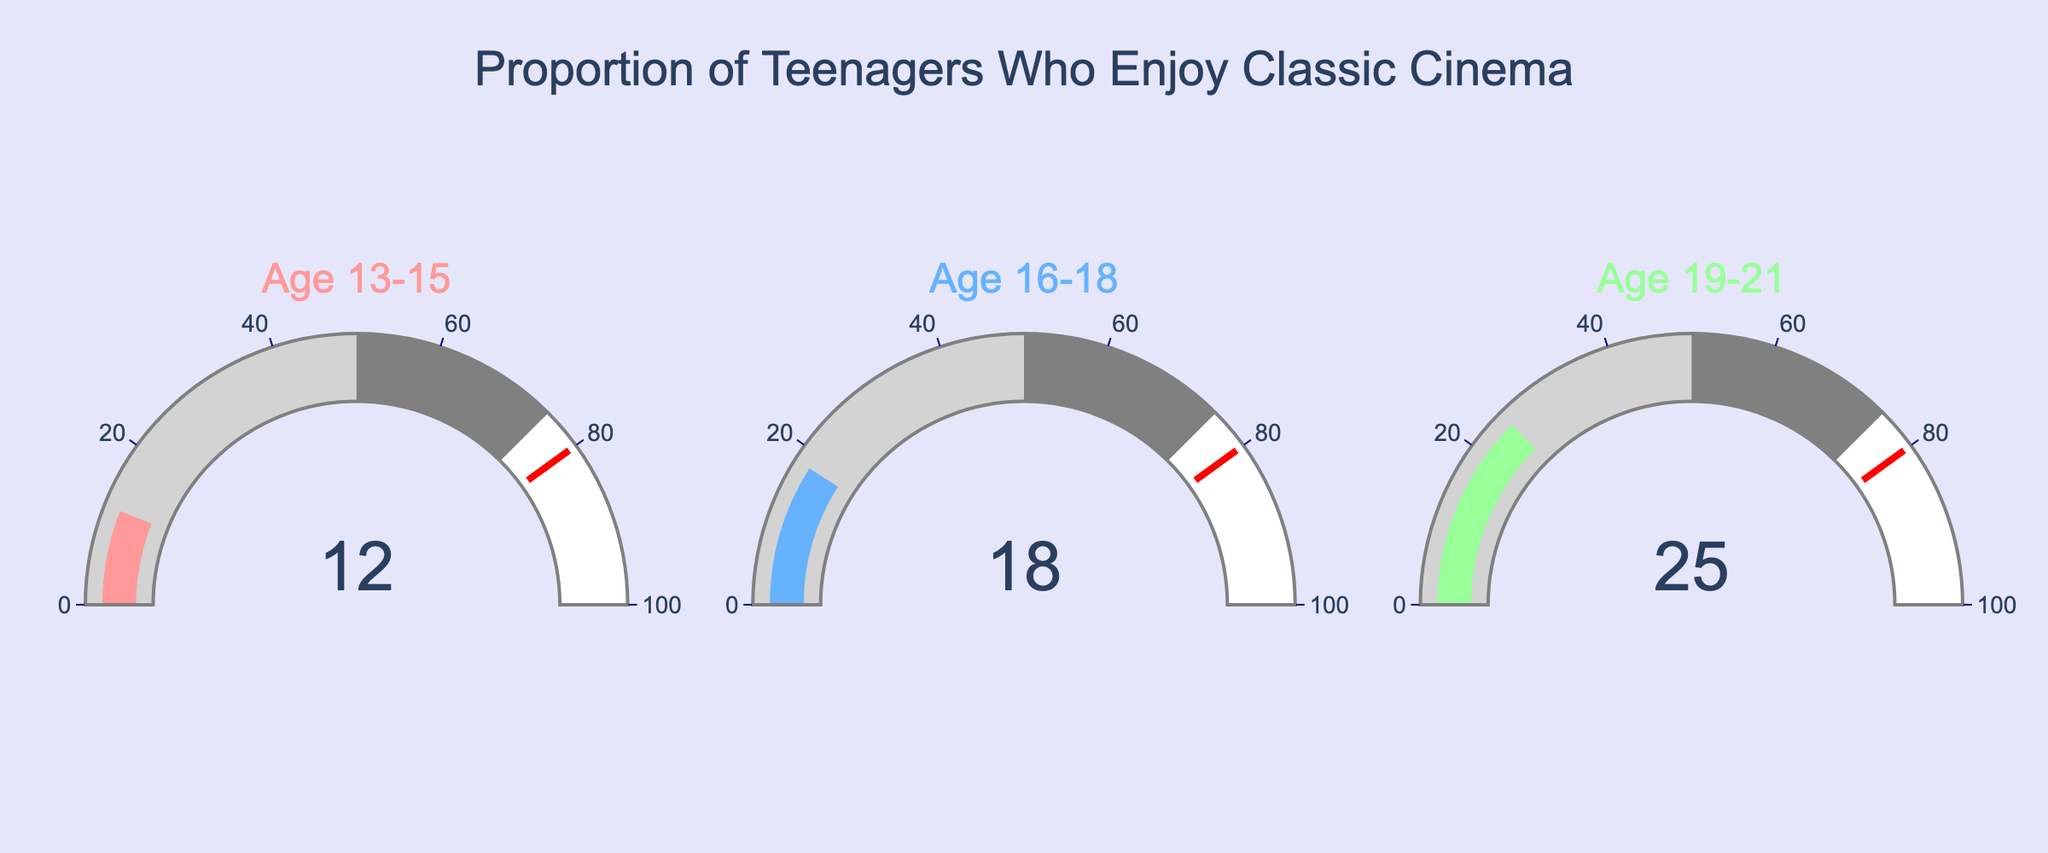What is the percentage of teenagers aged 13-15 who enjoy classic cinema? According to the gauge chart displaying the data, the percentage of teenagers aged 13-15 who enjoy classic cinema is clearly shown.
Answer: 12% What is the title of the gauge chart? The title of the gauge chart is displayed at the top center of the chart and reads "Proportion of Teenagers Who Enjoy Classic Cinema".
Answer: Proportion of Teenagers Who Enjoy Classic Cinema Which age group has the highest percentage of enjoyment for classic cinema? By comparing the values displayed on all three gauges, it's evident that the age group with the highest percentage is the one with the highest number. The chart shows 25% for the 19-21 age group, which is the highest value.
Answer: 19-21 What is the difference in percentage between the 16-18 age group and the 13-15 age group? The gauge for the 16-18 age group shows 18%, and the gauge for the 13-15 age group shows 12%. So, the difference is calculated as 18% - 12% = 6%.
Answer: 6% What is the average percentage of enjoyment across all three age groups? To find the average, sum the percentages of all three age groups and then divide by the number of age groups. The values are 12%, 18%, and 25%. Thus, (12 + 18 + 25) / 3 = 55 / 3 = 18.33%.
Answer: 18.33% What's the range of the gauge scales? Each of the gauge charts has an axis labeled with a range from 0 to 100, as indicated by the tick marks.
Answer: 0 to 100 Are any of the age groups below 15% in enjoying classic cinema? By examining the values on the gauges, only the age group 13-15 has a value below 15%, which is 12%.
Answer: Yes What color is used to display the gauge value for the 16-18 age group? The gauge for the 16-18 age group uses a blue color to display its value, as observed from its visual appearance.
Answer: Blue Which age group shows a percentage closer to the threshold value on the gauge? The threshold value marked is 80%. Among the percentages 12%, 18%, and 25%, the 25% of the 19-21 age group is the closest.
Answer: 19-21 What colors are used for highlighting the different ranges in each gauge? Each gauge shows a gradient where light gray is used for ranges from 0 to 50, and gray is used for ranges from 50 to 75.
Answer: Light gray and gray 